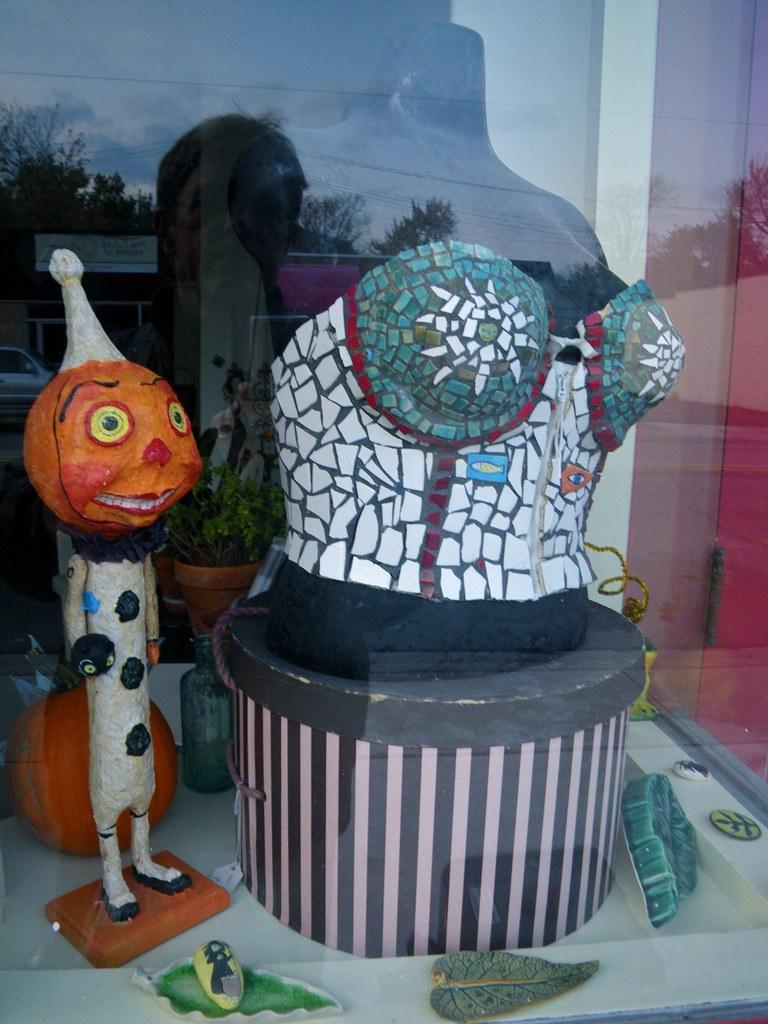What is located in the center of the image? There are toys in the center of the image. How many elbows can be seen on the toys in the image? There is no mention of elbows on the toys in the image, so it is not possible to determine the number of elbows. 